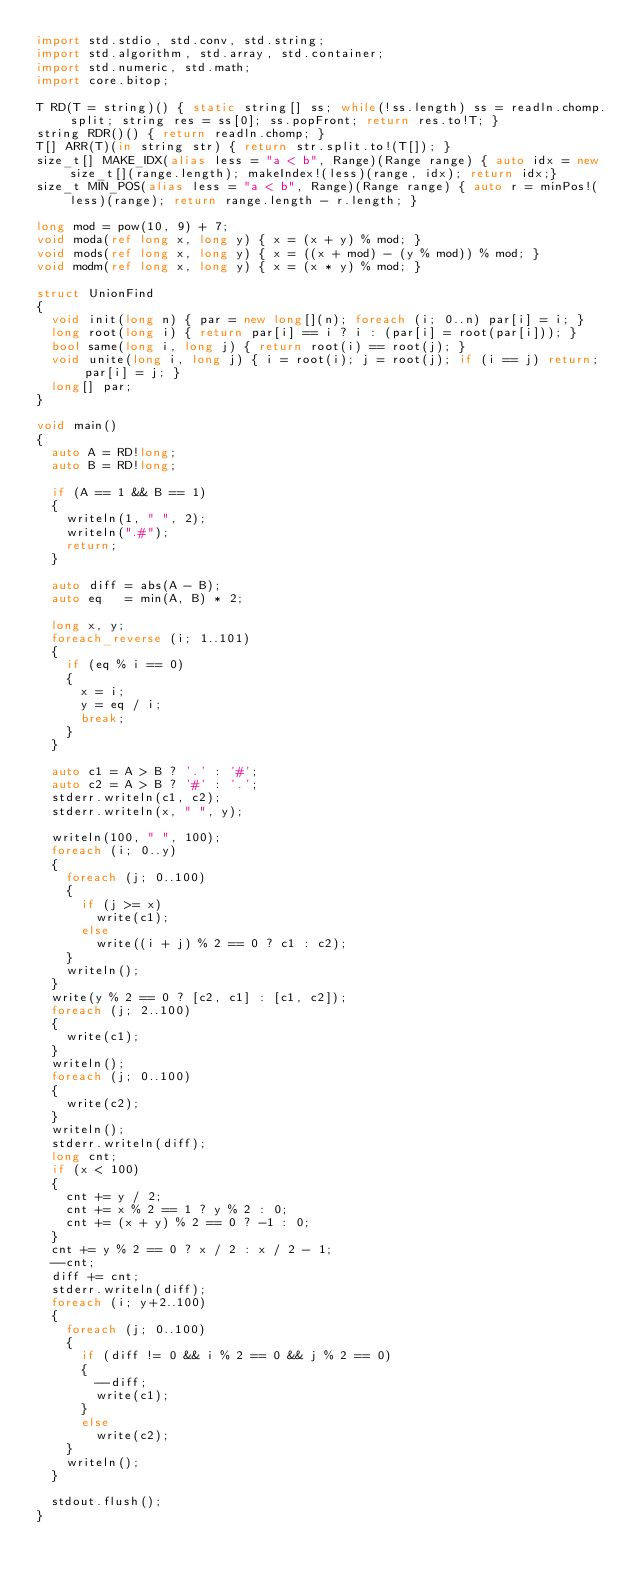<code> <loc_0><loc_0><loc_500><loc_500><_D_>import std.stdio, std.conv, std.string;
import std.algorithm, std.array, std.container;
import std.numeric, std.math;
import core.bitop;

T RD(T = string)() { static string[] ss; while(!ss.length) ss = readln.chomp.split; string res = ss[0]; ss.popFront; return res.to!T; }
string RDR()() { return readln.chomp; }
T[] ARR(T)(in string str) { return str.split.to!(T[]); }
size_t[] MAKE_IDX(alias less = "a < b", Range)(Range range) { auto idx = new size_t[](range.length); makeIndex!(less)(range, idx); return idx;}
size_t MIN_POS(alias less = "a < b", Range)(Range range) { auto r = minPos!(less)(range); return range.length - r.length; }

long mod = pow(10, 9) + 7;
void moda(ref long x, long y) { x = (x + y) % mod; }
void mods(ref long x, long y) { x = ((x + mod) - (y % mod)) % mod; }
void modm(ref long x, long y) { x = (x * y) % mod; }

struct UnionFind
{
	void init(long n) { par = new long[](n); foreach (i; 0..n) par[i] = i; }
	long root(long i) { return par[i] == i ? i : (par[i] = root(par[i])); }
	bool same(long i, long j) { return root(i) == root(j); }
	void unite(long i, long j) { i = root(i); j = root(j); if (i == j) return; par[i] = j; }
	long[] par;
}

void main()
{
	auto A = RD!long;
	auto B = RD!long;

	if (A == 1 && B == 1)
	{
		writeln(1, " ", 2);
		writeln(".#");
		return;
	}

	auto diff = abs(A - B);
	auto eq   = min(A, B) * 2; 

	long x, y;
	foreach_reverse (i; 1..101)
	{
		if (eq % i == 0)
		{
			x = i;
			y = eq / i;
			break;
		}
	}

	auto c1 = A > B ? '.' : '#';
	auto c2 = A > B ? '#' : '.';
	stderr.writeln(c1, c2);
	stderr.writeln(x, " ", y);

	writeln(100, " ", 100);
	foreach (i; 0..y)
	{
		foreach (j; 0..100)
		{
			if (j >= x)
				write(c1);
			else
				write((i + j) % 2 == 0 ? c1 : c2);
		}
		writeln();
	}
	write(y % 2 == 0 ? [c2, c1] : [c1, c2]);
	foreach (j; 2..100)
	{
		write(c1);
	}
	writeln();
	foreach (j; 0..100)
	{
		write(c2);
	}
	writeln();
	stderr.writeln(diff);
	long cnt;
	if (x < 100)
	{
		cnt += y / 2;
		cnt += x % 2 == 1 ? y % 2 : 0;
		cnt += (x + y) % 2 == 0 ? -1 : 0;
	}
	cnt += y % 2 == 0 ? x / 2 : x / 2 - 1;
	--cnt;
	diff += cnt;
	stderr.writeln(diff);
	foreach (i; y+2..100)
	{
		foreach (j; 0..100)
		{
			if (diff != 0 && i % 2 == 0 && j % 2 == 0)
			{
				--diff;
				write(c1);
			}
			else
				write(c2);
		}
		writeln();
	}

	stdout.flush();
}</code> 